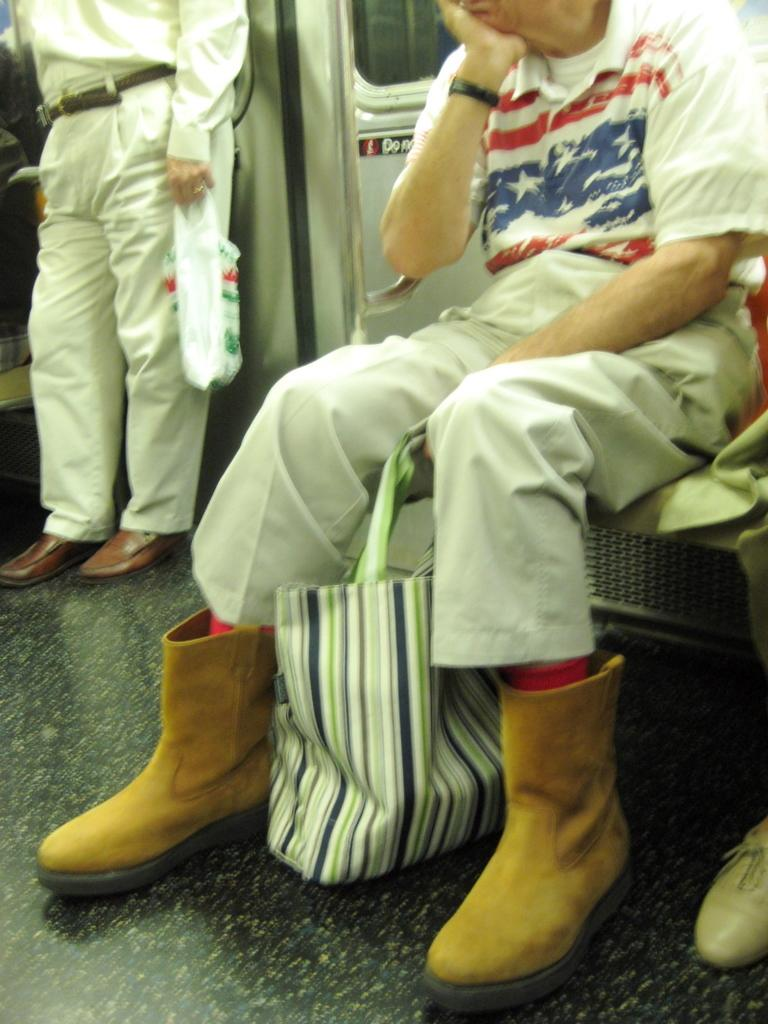What is the person in the vehicle doing? The person is seated on a chair in the vehicle. What is the person holding in their hand? The person is holding a bag in their hand. What type of fish can be seen swimming in the prison in the image? There is no prison or fish present in the image; it features a person seated in a vehicle holding a bag. 